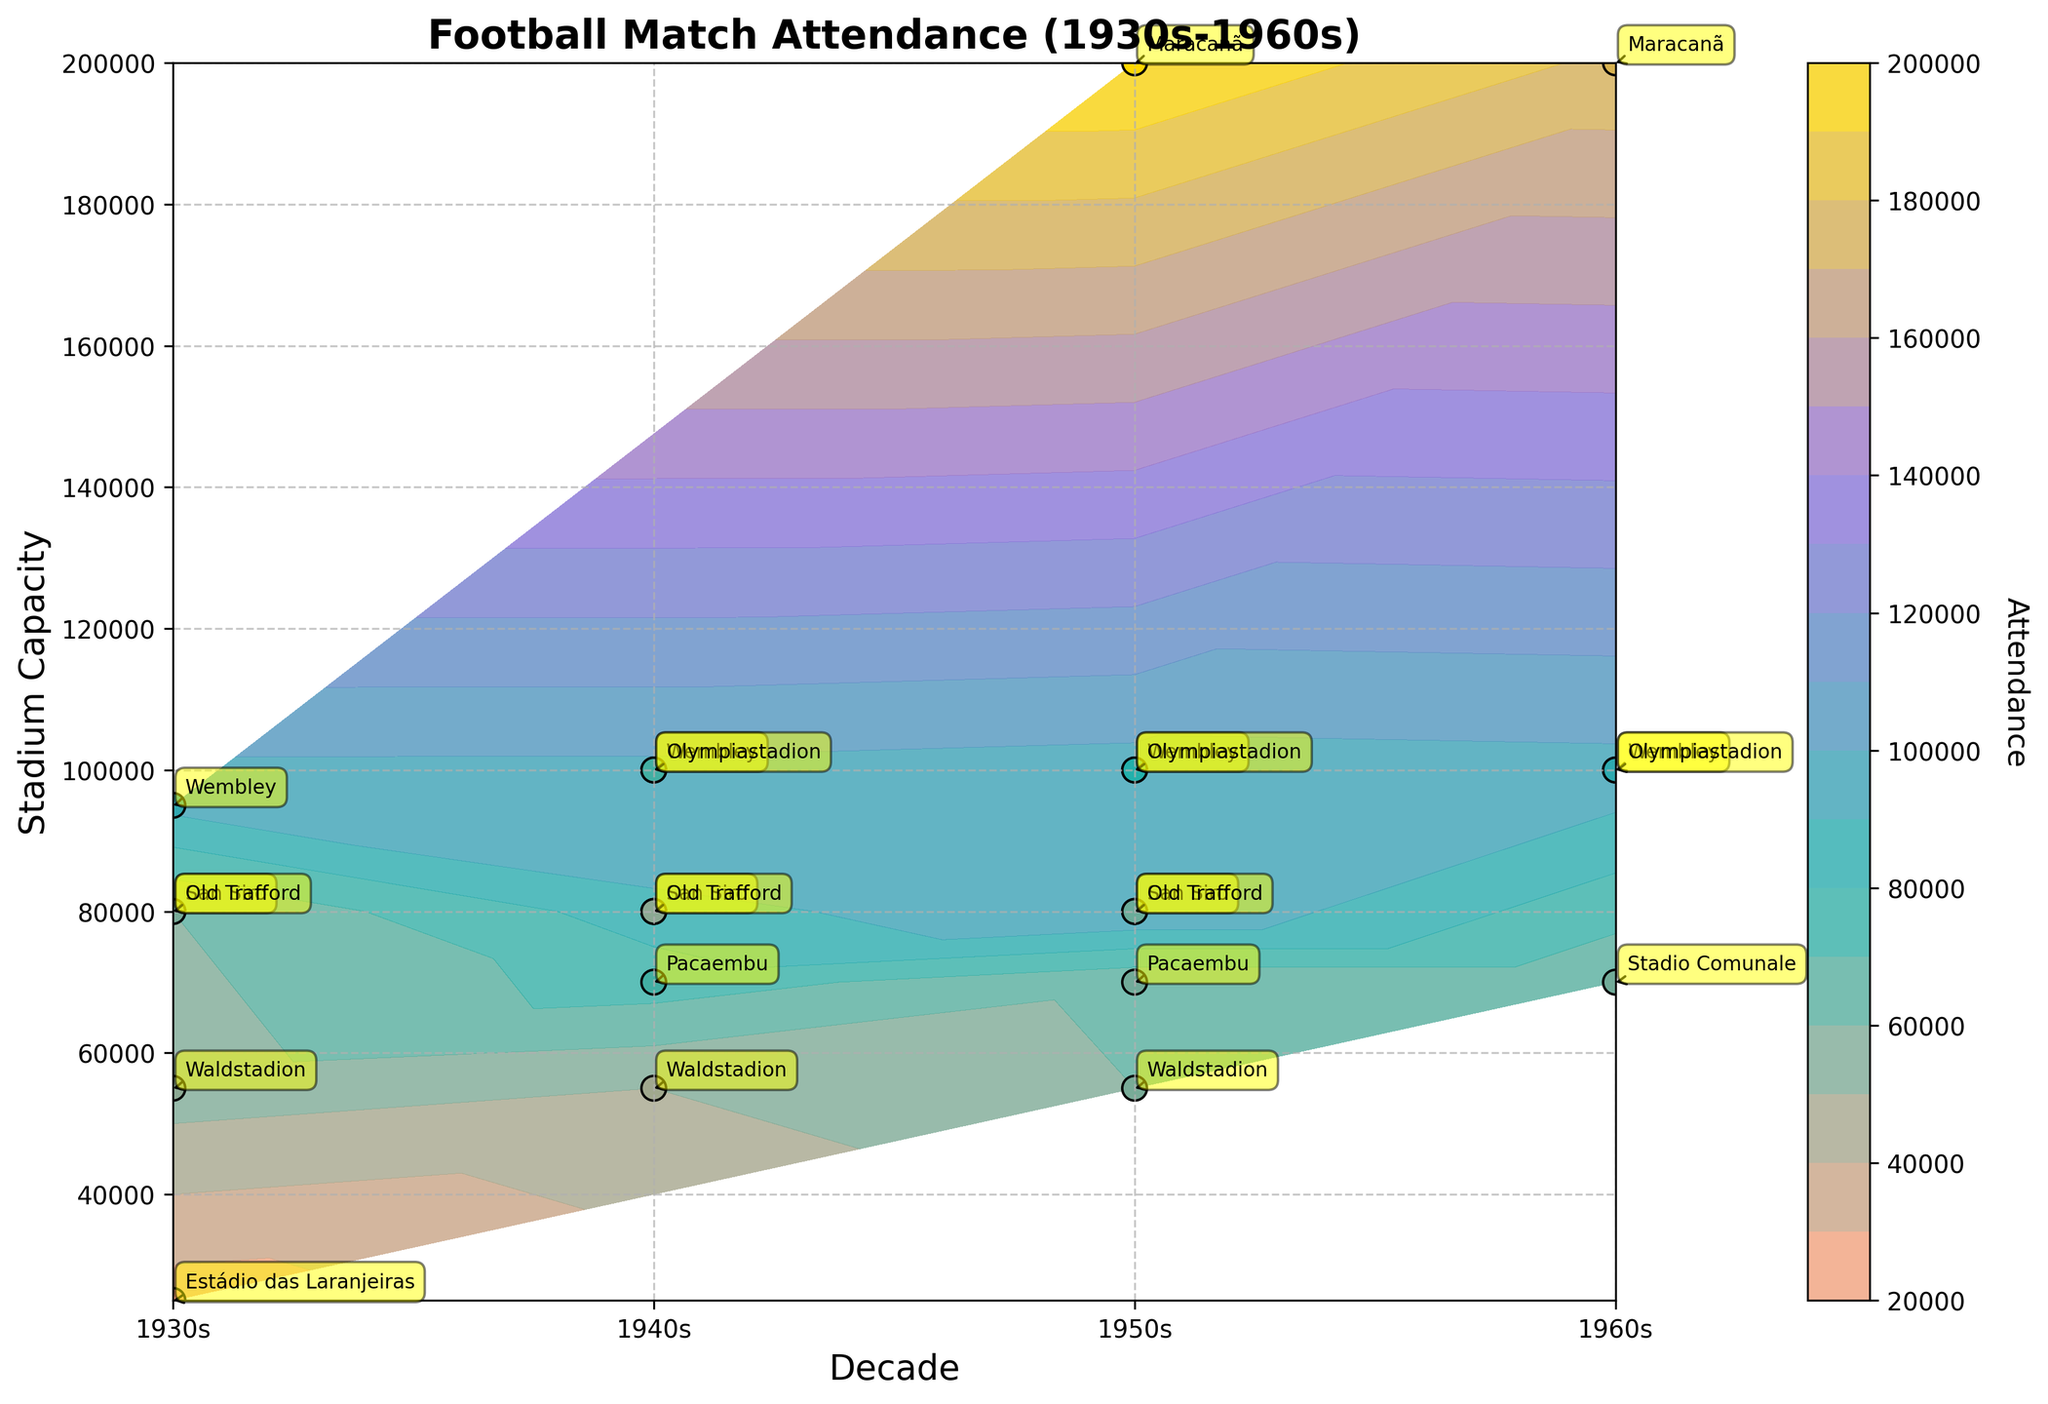what is the title of the figure? The title is the bold text displayed at the top of the plot, which describes the overall subject and time frame of the data visualized. Here, the title is "Football Match Attendance (1930s-1960s)" and it is shown at the top of the plot.
Answer: Football Match Attendance (1930s-1960s) Which decade shows the highest concentration of attendance data points? By examining the density of data points in the form of scatter plot markers, it is evident that the 1950s and 1960s have more data points compared to the 1930s and 1940s. This indicates higher concentration in these decades.
Answer: 1950s and 1960s What stadium has the highest recorded attendance and in which decade? By identifying the highest point on the 'Attendance' color scale (most intense color and marker), Maracanã stadium in Brazil in the 1950s holds the highest attendance figure, as indicated by the contour plot. The plotted point at roughly 200,000 attendees corresponds to the 1950s.
Answer: Maracanã, 1950s What are the x and y-axis labels on the figure? The labels along the horizontal (x) axis describe the time period 'Decade', while the labels along the vertical (y) axis denote 'Stadium Capacity'. These are found at the bottom and the side of the graph, respectively.
Answer: Decade, Stadium Capacity Which country shows the most consistent high attendance across the decades? By observing the scatter of attendance points and their colors across different decades, England's Wembley stadium consistently shows high attendance figures close to its maximum capacity in all plotted decades: 1930s to 1960s.
Answer: England Compare the attendance figures in the 1940s for Olympiastadion in Germany and San Siro in Italy. The scatter plot markers can be used to compare. Olympiastadion shows an attendance of 75,000 and San Siro shows an attendance of 85,000 in the 1940s, observed through their positions on the y-axis and the coloring.
Answer: San Siro has higher attendance Which stadium had zero increase in capacity over the decades? Analyzing the scatter points for each stadium over different decades, Estádio das Laranjeiras in Brazil shows a constant capacity of 25,000 without growth from the 1930s.
Answer: Estádio das Laranjeiras How does the attendance at Wembley stadium change over the decades? Tracking the scatter points specifically labeled 'Wembley' from 1930s to 1960s, Wembley maintains a high and consistent attendance, ranging between 93,000 to 98,000 over the 4 decades.
Answer: Remains high and consistent What colors are used to represent different attendance levels in the contour plot? The contour plot uses a gradient of colors to represent different attendance levels: Light Salmon, Light Sea Green, Medium Purple, and Gold. These colors progressively represent varying attendance densities from low to high.
Answer: Light Salmon, Light Sea Green, Medium Purple, Gold Which stadium in Germany shows a significant change in attendance from the 1930s to the 1950s? Comparing data points, Waldstadion shows a significant rise in attendance from 55,000 in the 1930s to 60,000 in the 1950s, as seen from the change in position along the y-axis and color changes indicating increased attendance.
Answer: Waldstadion 